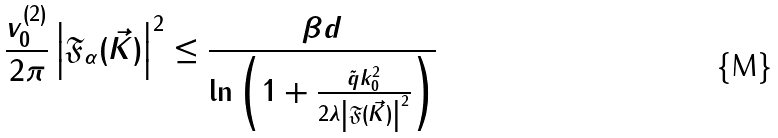<formula> <loc_0><loc_0><loc_500><loc_500>\frac { v _ { 0 } ^ { ( 2 ) } } { 2 \pi } \left | \mathfrak { F } _ { \alpha } ( \vec { K } ) \right | ^ { 2 } \leq \frac { \beta d } { \ln \left ( 1 + \frac { \tilde { q } k _ { 0 } ^ { 2 } } { 2 \lambda \left | \mathfrak { F } ( \vec { K } ) \right | ^ { 2 } } \right ) }</formula> 